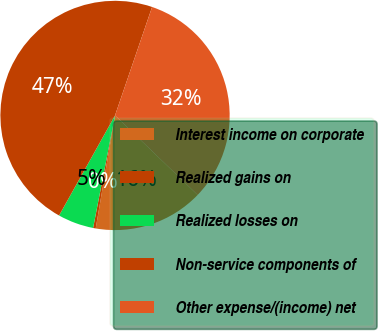Convert chart to OTSL. <chart><loc_0><loc_0><loc_500><loc_500><pie_chart><fcel>Interest income on corporate<fcel>Realized gains on<fcel>Realized losses on<fcel>Non-service components of<fcel>Other expense/(income) net<nl><fcel>15.5%<fcel>0.37%<fcel>5.05%<fcel>47.12%<fcel>31.95%<nl></chart> 